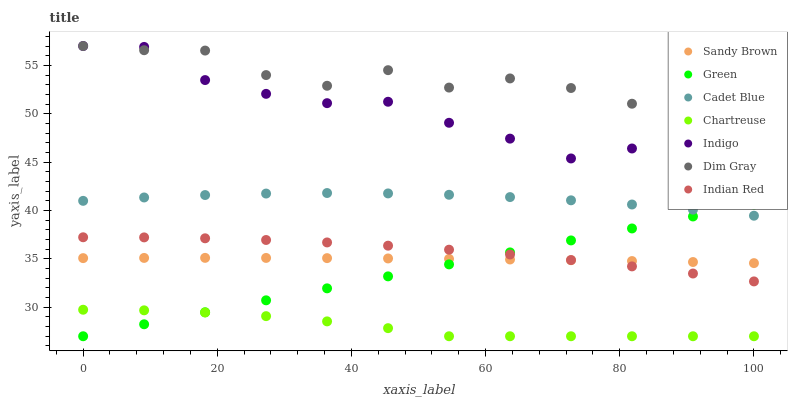Does Chartreuse have the minimum area under the curve?
Answer yes or no. Yes. Does Dim Gray have the maximum area under the curve?
Answer yes or no. Yes. Does Indigo have the minimum area under the curve?
Answer yes or no. No. Does Indigo have the maximum area under the curve?
Answer yes or no. No. Is Green the smoothest?
Answer yes or no. Yes. Is Indigo the roughest?
Answer yes or no. Yes. Is Chartreuse the smoothest?
Answer yes or no. No. Is Chartreuse the roughest?
Answer yes or no. No. Does Chartreuse have the lowest value?
Answer yes or no. Yes. Does Indigo have the lowest value?
Answer yes or no. No. Does Indigo have the highest value?
Answer yes or no. Yes. Does Chartreuse have the highest value?
Answer yes or no. No. Is Chartreuse less than Indian Red?
Answer yes or no. Yes. Is Cadet Blue greater than Chartreuse?
Answer yes or no. Yes. Does Green intersect Sandy Brown?
Answer yes or no. Yes. Is Green less than Sandy Brown?
Answer yes or no. No. Is Green greater than Sandy Brown?
Answer yes or no. No. Does Chartreuse intersect Indian Red?
Answer yes or no. No. 